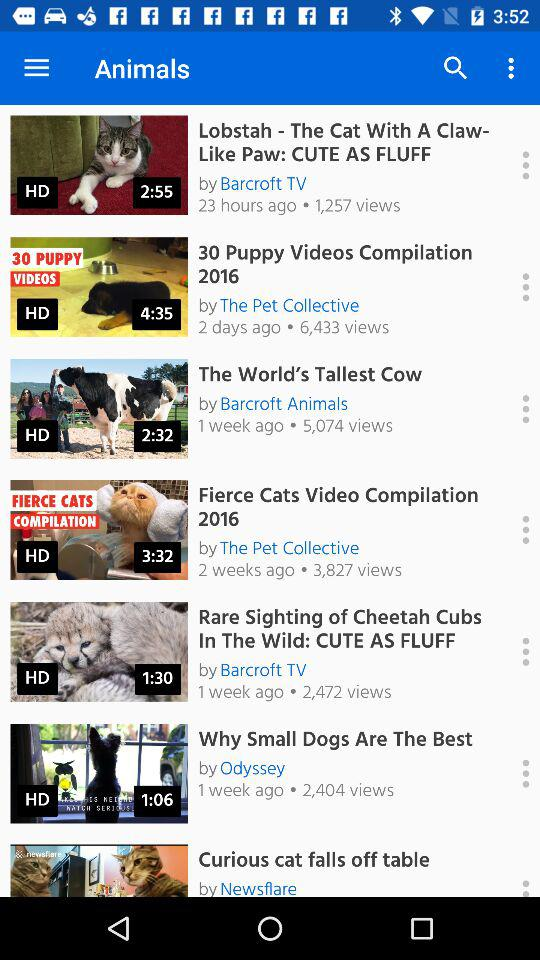Who uploaded the "Lobstah" video? The "Lobstah" was uploaded by "Barcroft TV". 